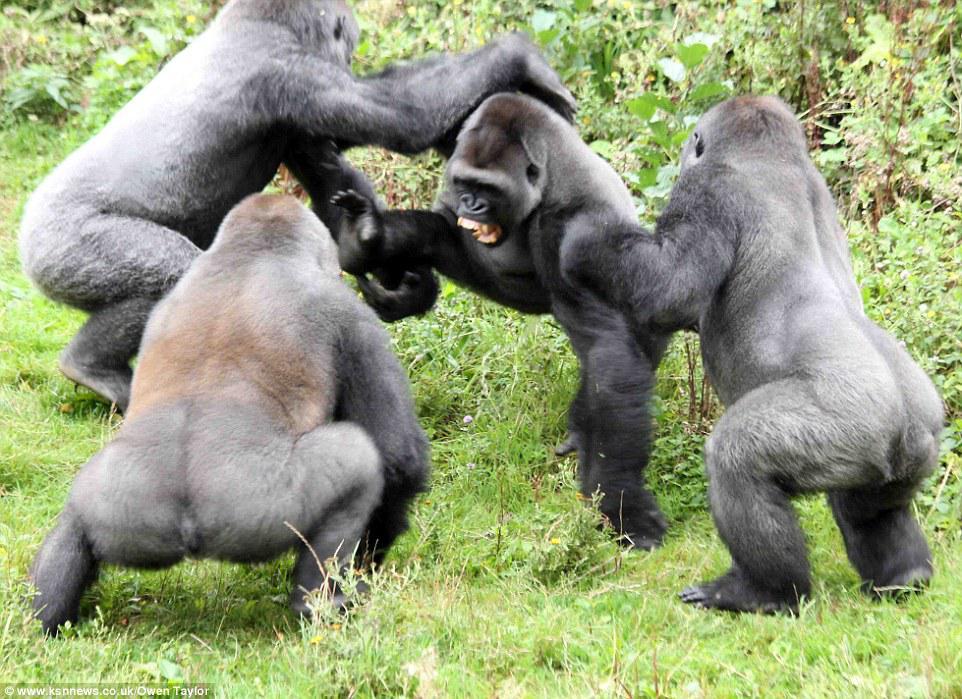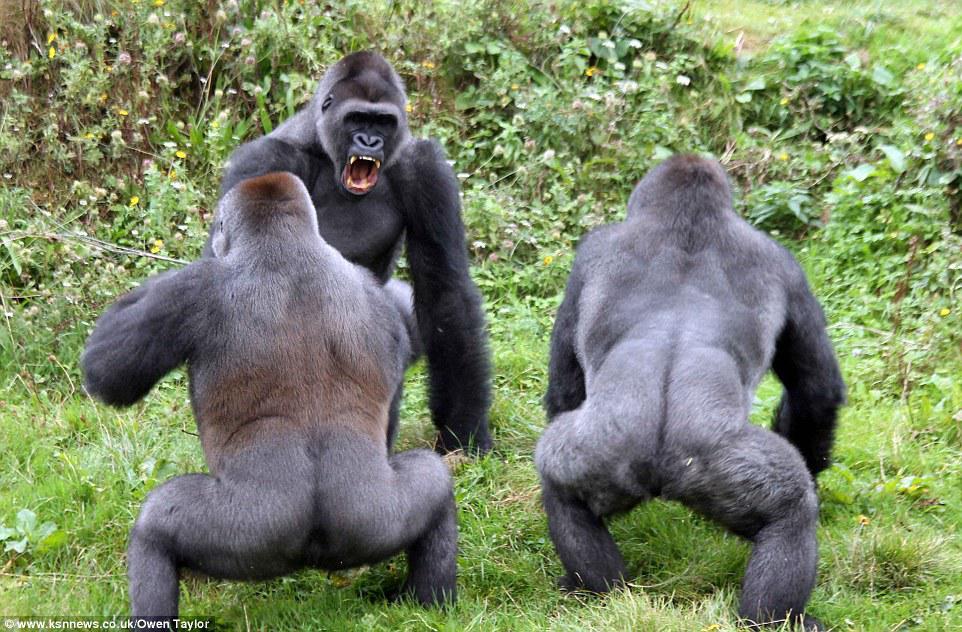The first image is the image on the left, the second image is the image on the right. Evaluate the accuracy of this statement regarding the images: "At least one image shows upright gorillas engaged in a confrontation, with at least one gorilla's back turned to the camera and one gorilla with fangs bared.". Is it true? Answer yes or no. Yes. The first image is the image on the left, the second image is the image on the right. Given the left and right images, does the statement "The gorillas are fighting." hold true? Answer yes or no. Yes. 